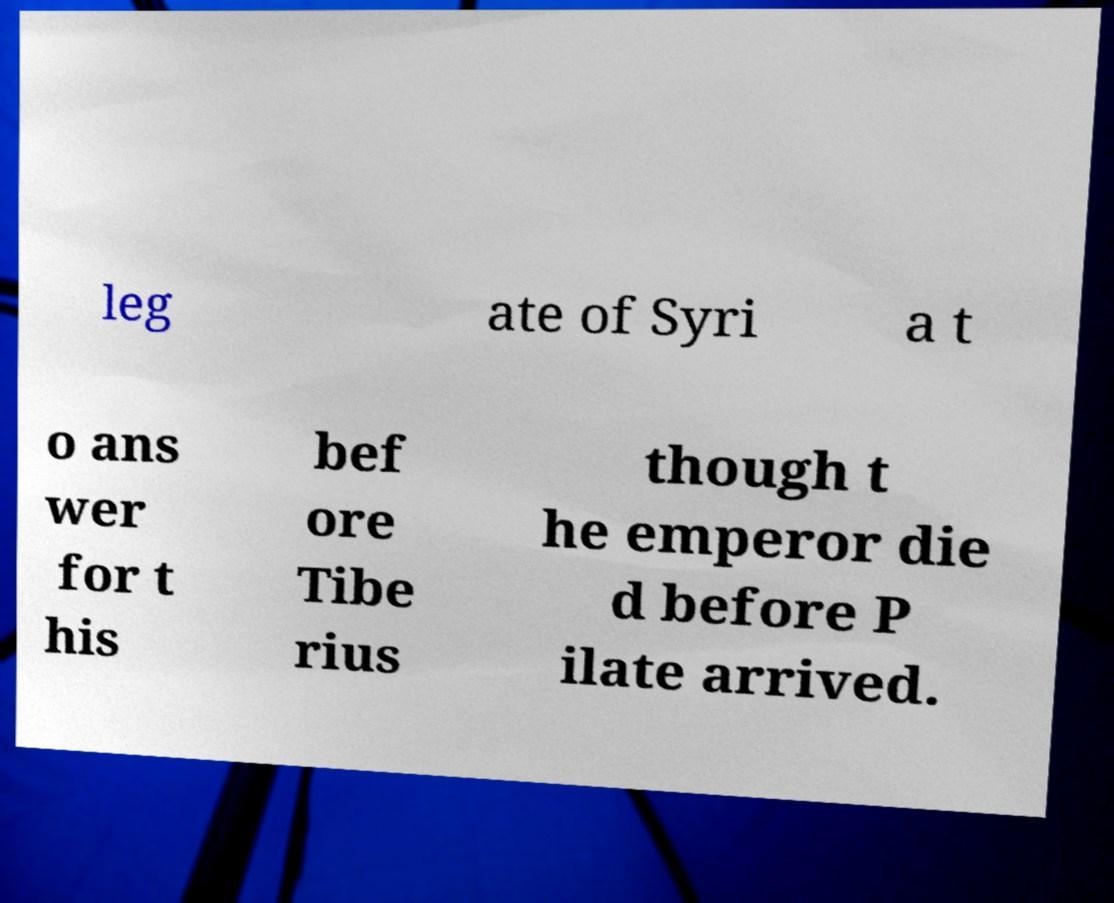What messages or text are displayed in this image? I need them in a readable, typed format. leg ate of Syri a t o ans wer for t his bef ore Tibe rius though t he emperor die d before P ilate arrived. 